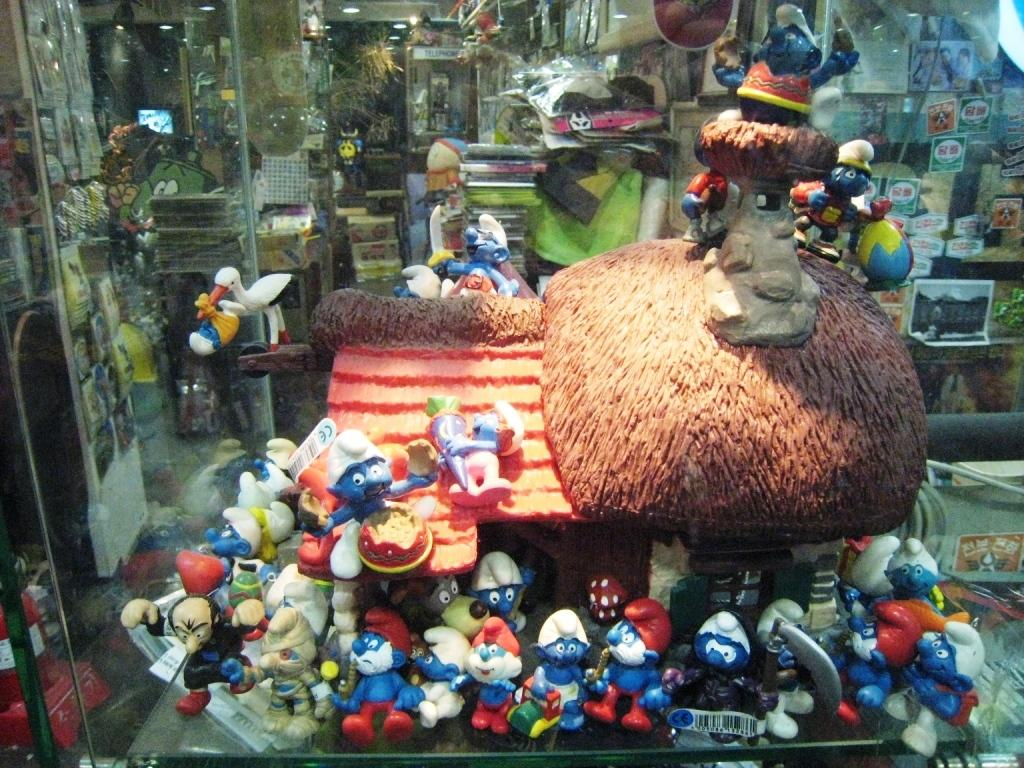What type of objects can be seen in the image? There are toys in the image. What type of storage furniture is present in the image? There are glass cupboards in the image. What type of illumination is present in the image? There are lights in the image. Can you describe any other objects visible in the image? There are other objects in the image, but their specific details are not mentioned in the provided facts. What type of flesh can be seen in the image? There is no flesh present in the image. What type of bone is visible in the image? There is no bone visible in the image. What type of rail is present in the image? There is no rail present in the image. 